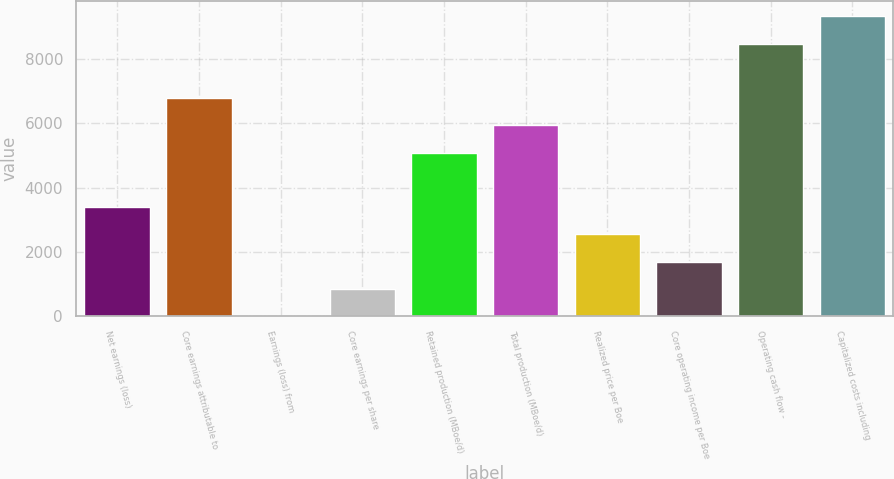Convert chart to OTSL. <chart><loc_0><loc_0><loc_500><loc_500><bar_chart><fcel>Net earnings (loss)<fcel>Core earnings attributable to<fcel>Earnings (loss) from<fcel>Core earnings per share<fcel>Retained production (MBoe/d)<fcel>Total production (MBoe/d)<fcel>Realized price per Boe<fcel>Core operating income per Boe<fcel>Operating cash flow -<fcel>Capitalized costs including<nl><fcel>3389.87<fcel>6779.27<fcel>0.47<fcel>847.82<fcel>5084.57<fcel>5931.92<fcel>2542.52<fcel>1695.17<fcel>8473.97<fcel>9321.32<nl></chart> 